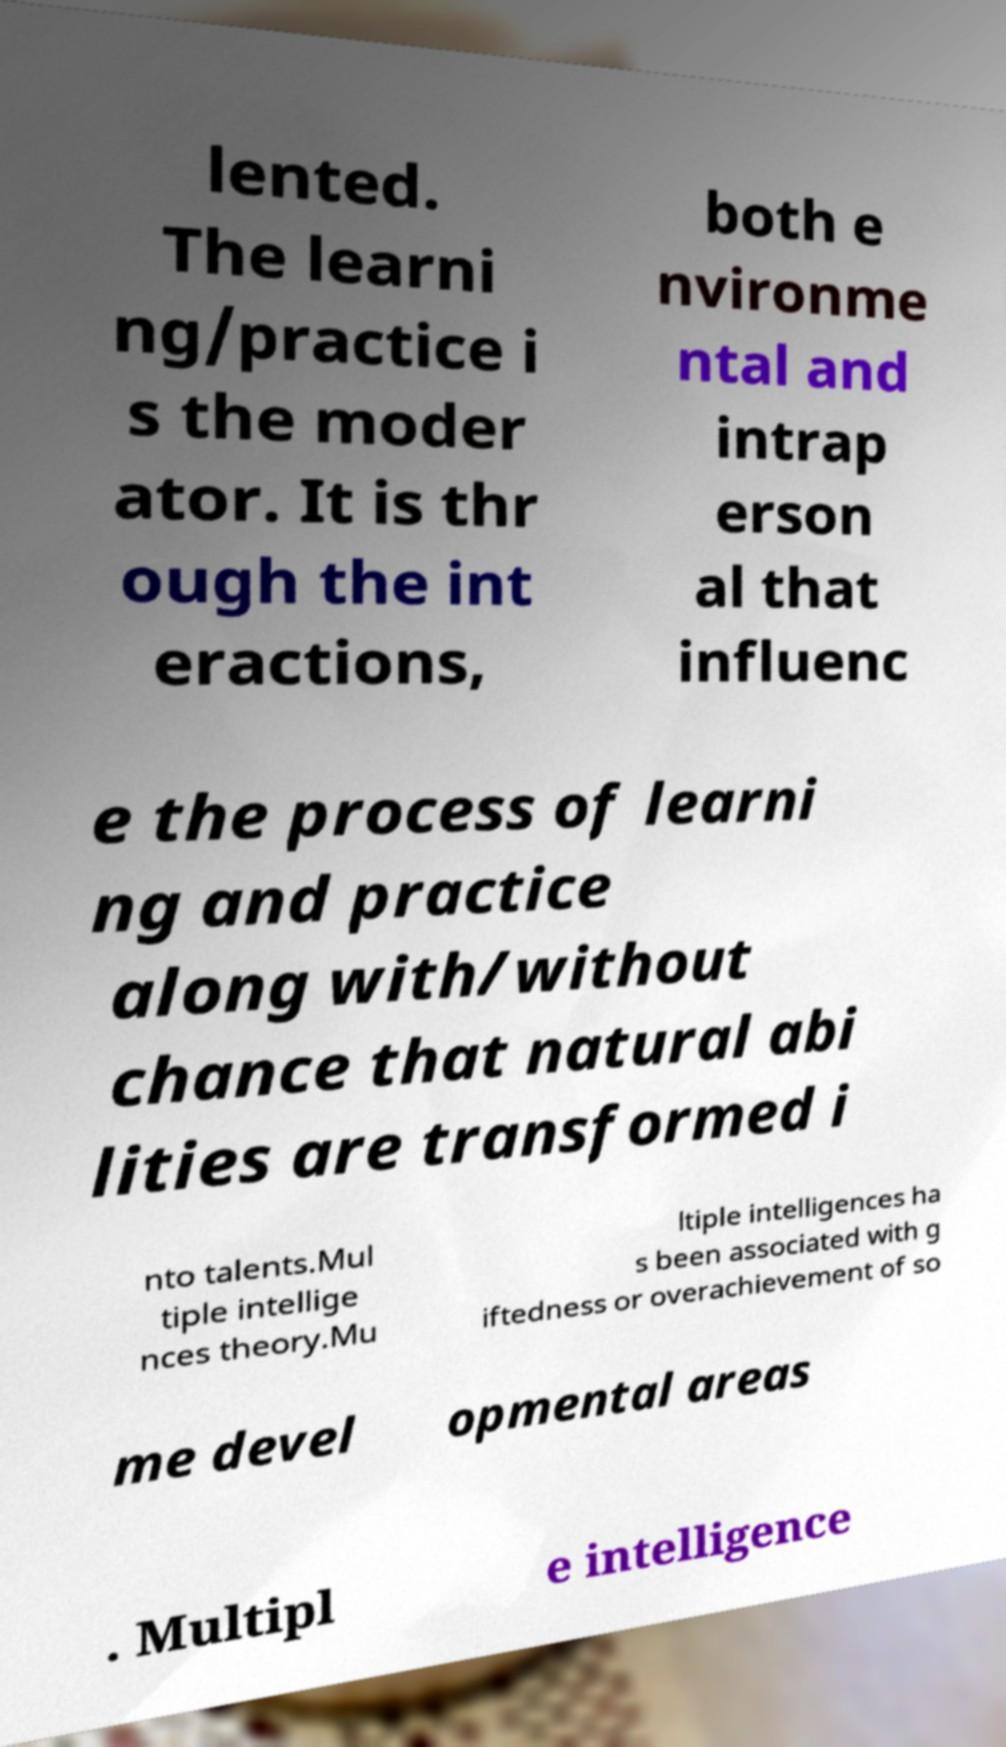Could you assist in decoding the text presented in this image and type it out clearly? lented. The learni ng/practice i s the moder ator. It is thr ough the int eractions, both e nvironme ntal and intrap erson al that influenc e the process of learni ng and practice along with/without chance that natural abi lities are transformed i nto talents.Mul tiple intellige nces theory.Mu ltiple intelligences ha s been associated with g iftedness or overachievement of so me devel opmental areas . Multipl e intelligence 